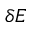Convert formula to latex. <formula><loc_0><loc_0><loc_500><loc_500>\delta E</formula> 